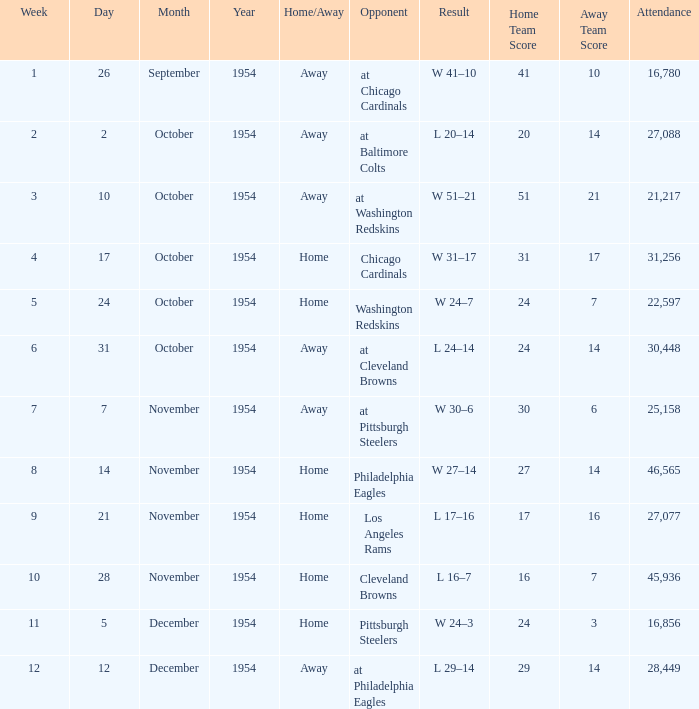How many weeks have october 31, 1954 as the date? 1.0. 